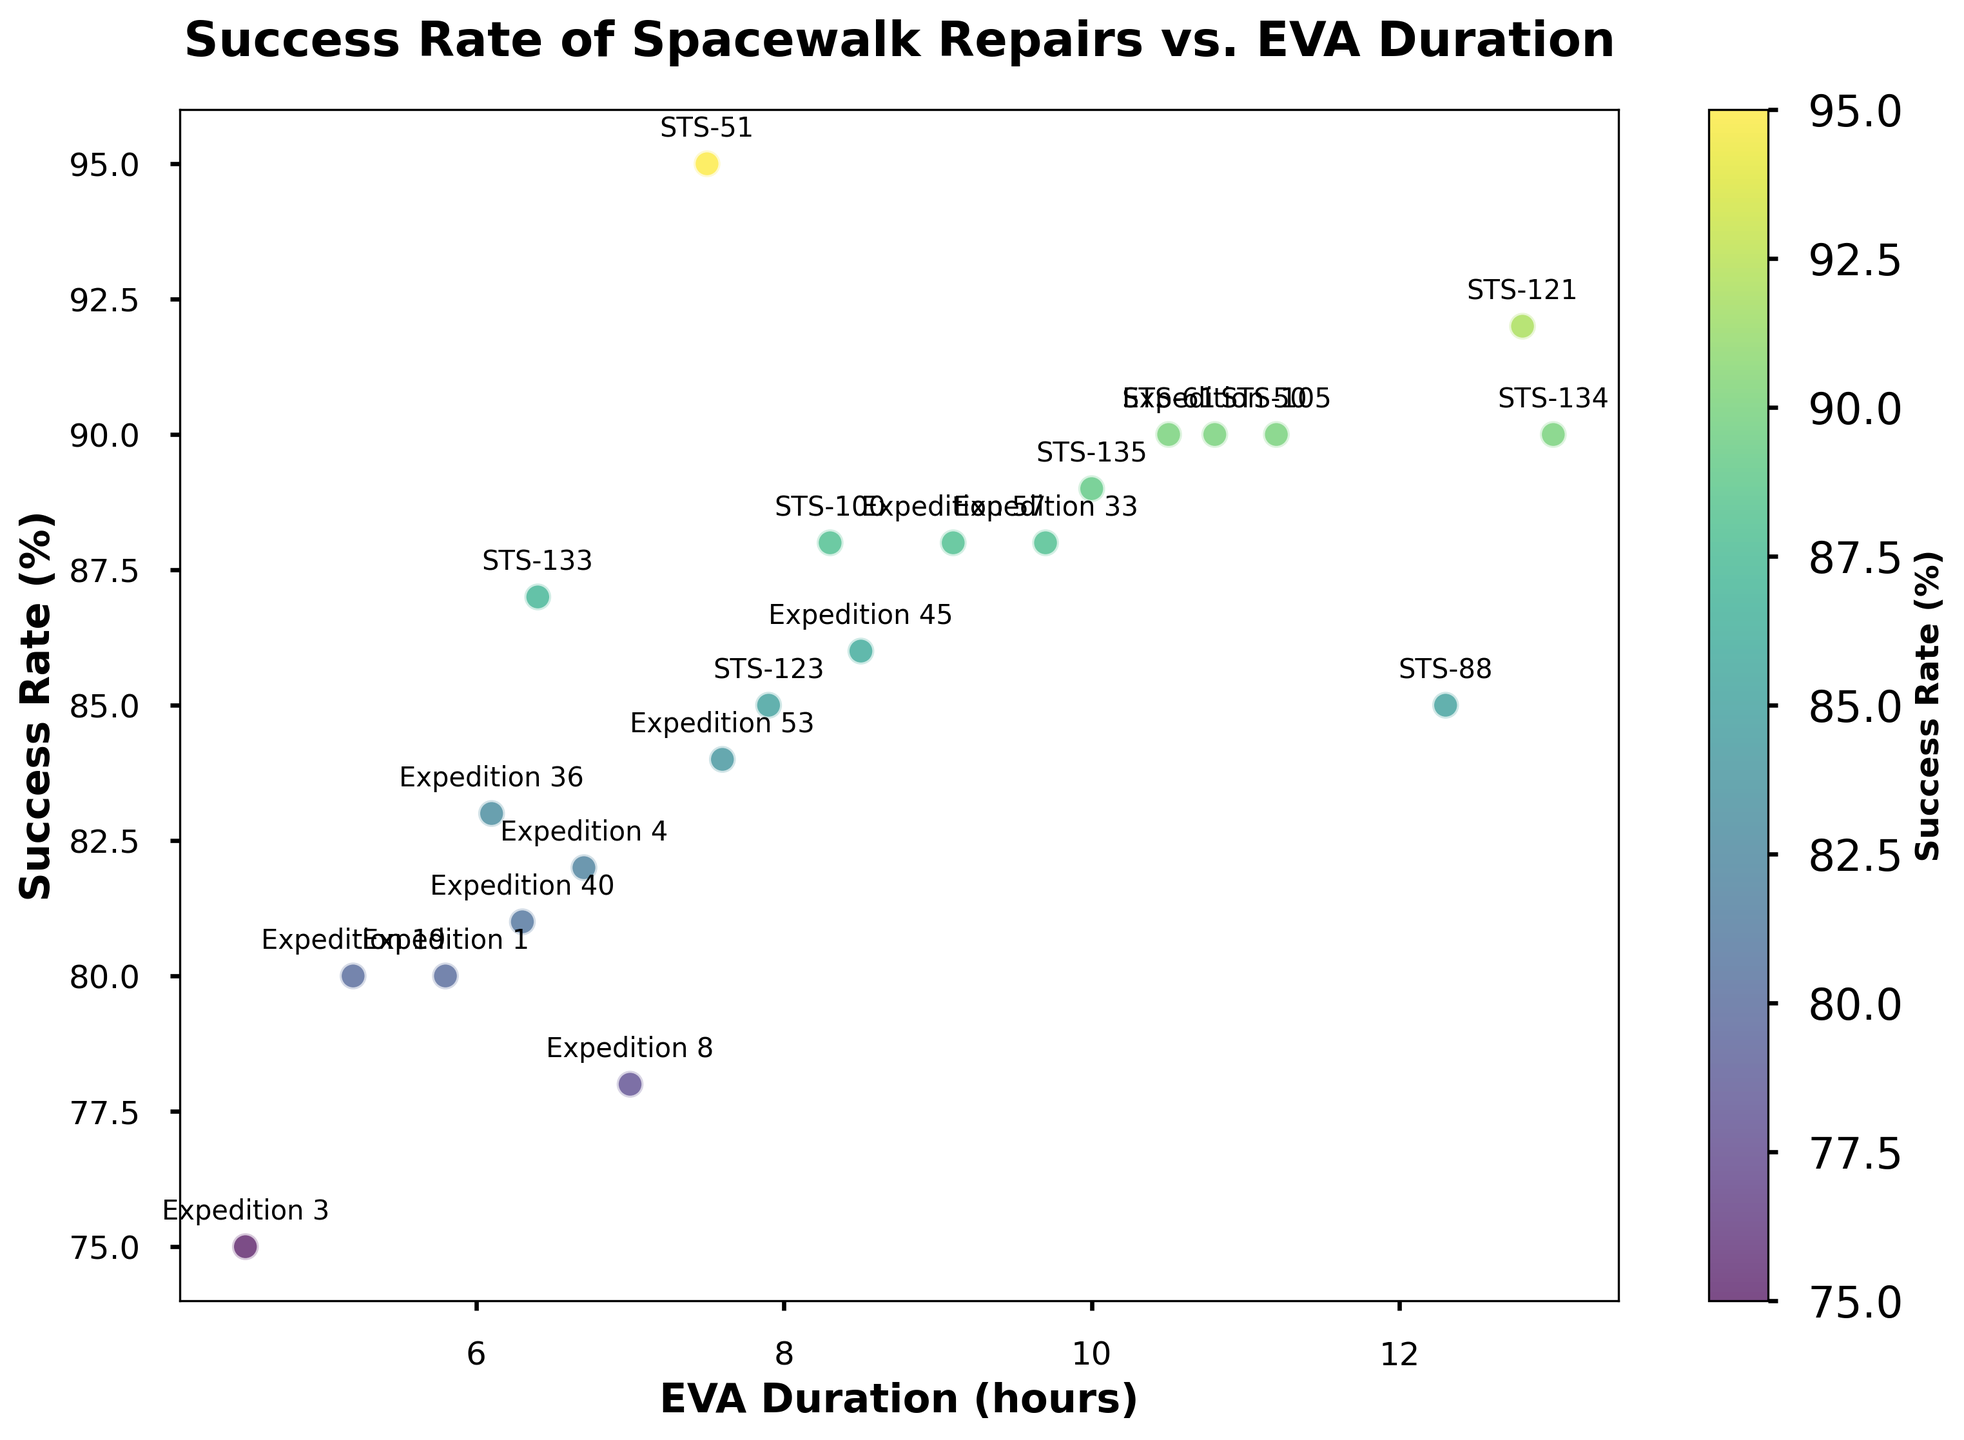Which mission has the highest success rate? The mission with the highest success rate can be identified by looking at the highest point on the y-axis (Success Rate). STS-51, which has a success rate of 95%, is the highest point.
Answer: STS-51 Which mission had the longest EVA duration? The mission with the longest EVA duration can be identified by looking at the rightmost point on the x-axis (EVA Duration). STS-134 had an EVA duration of 13.0 hours, which is the longest.
Answer: STS-134 Is there a correlation between EVA duration and success rate? The scatter plot shows a trend where missions with longer EVA durations generally have higher success rates. For instance, missions like STS-134 and STS-121 have both high EVA durations and high success rates, suggesting a positive correlation.
Answer: Yes, there is a positive correlation What is the average EVA duration for missions with a success rate above 90%? First, list the missions with success rates above 90%, then find their average EVA duration. The missions are STS-51 (7.5 hours), STS-121 (12.8 hours), STS-135 (10.0 hours), Expedition 50 (10.8 hours). Adding these durations gives 41.1 hours, and the average is 41.1 / 4 = 10.275 hours.
Answer: 10.275 hours Which two missions have the closest EVA durations, and what are their durations? Looking closely at the plot, STS-123 and Expedition 53 have EVA durations close to each other. STS-123 has a duration of 7.9 hours, and Expedition 53 has a duration of 7.6 hours, making them almost identical in duration.
Answer: STS-123 (7.9 hours) and Expedition 53 (7.6 hours) How many missions had a success rate between 80% and 90%? Count all the data points that fall within the range of 80% to 90% on the y-axis. The relevant missions are: STS-88, STS-100, Expedition 4, Expedition 8, STS-123, STS-133, Expedition 33, Expedition 36, Expedition 45, Expedition 53, Expedition 57. There are 11 missions in total.
Answer: 11 missions Which mission has the lowest success rate, and what was its EVA duration? To find the lowest success rate, look for the lowest point on the y-axis. Expedition 3 has the lowest success rate at 75% and its EVA duration is 4.5 hours.
Answer: Expedition 3 (4.5 hours) Do missions with EVA durations less than 8 hours generally have lower success rates? List missions with EVA durations less than 8 hours and compare their success rates. These missions are Expedition 1 (5.8hr, 80%), Expedition 3 (4.5hr, 75%), Expedition 8 (7.0hr, 78%), STS-133 (6.4hr, 87%), Expedition 19 (5.2hr, 80%), Expedition 36 (6.1hr, 83%), Expedition 40 (6.3hr, 81%). Most of them have success rates below 90%.
Answer: Yes What is the median success rate for all missions in the dataset? Arrange all success rates: 75, 78, 80, 80, 81, 82, 83, 84, 85, 85, 86, 87, 88, 88, 88, 89, 90, 90, 90, 90, 92, 95. The median value, being the middle value in an ordered list with an odd number of elements, is halfway between the 11th and 12th values: (86 + 87)/2 = 86.5.
Answer: 86.5 